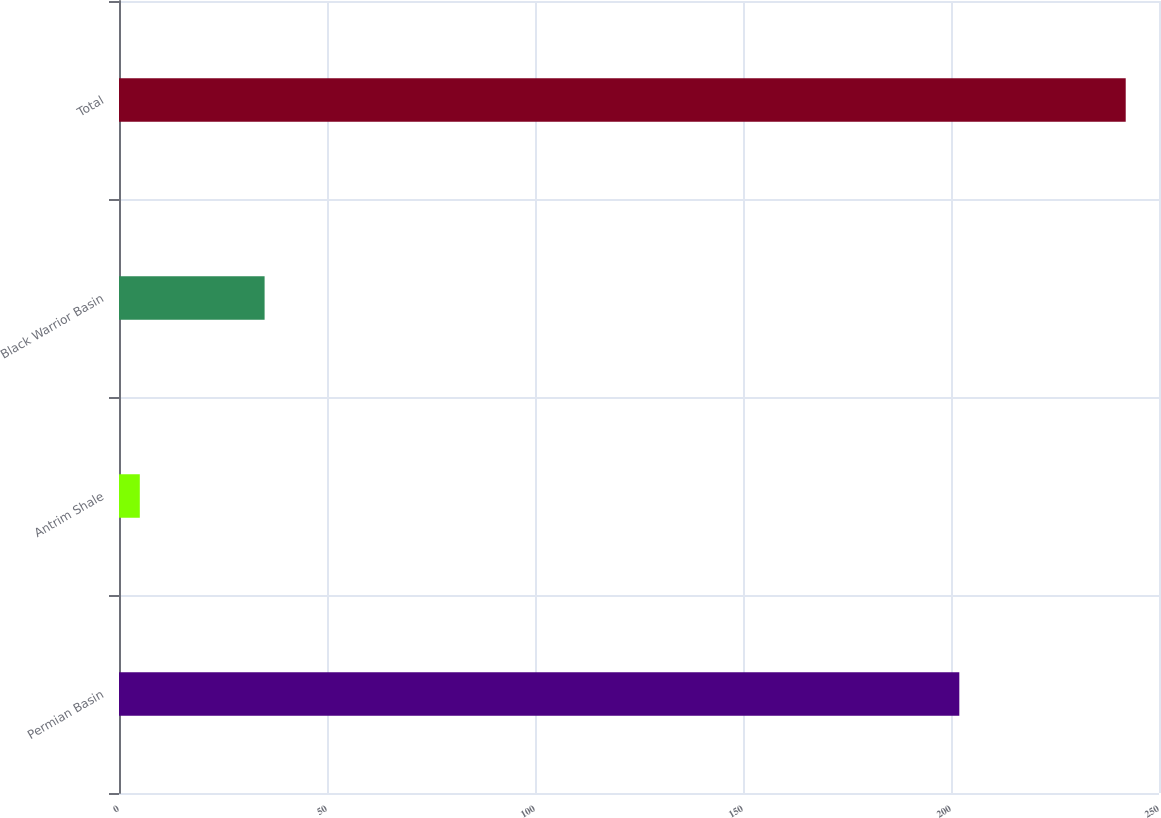<chart> <loc_0><loc_0><loc_500><loc_500><bar_chart><fcel>Permian Basin<fcel>Antrim Shale<fcel>Black Warrior Basin<fcel>Total<nl><fcel>202<fcel>5<fcel>35<fcel>242<nl></chart> 